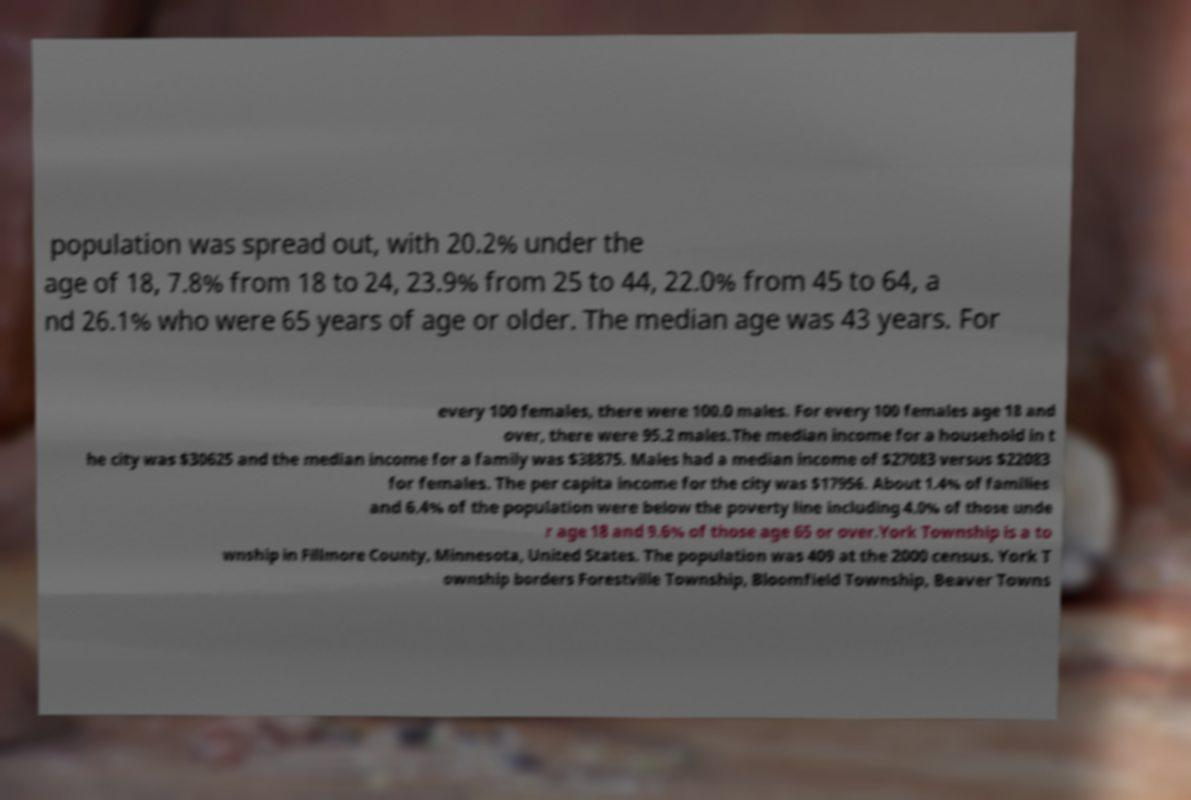What messages or text are displayed in this image? I need them in a readable, typed format. population was spread out, with 20.2% under the age of 18, 7.8% from 18 to 24, 23.9% from 25 to 44, 22.0% from 45 to 64, a nd 26.1% who were 65 years of age or older. The median age was 43 years. For every 100 females, there were 100.0 males. For every 100 females age 18 and over, there were 95.2 males.The median income for a household in t he city was $30625 and the median income for a family was $38875. Males had a median income of $27083 versus $22083 for females. The per capita income for the city was $17956. About 1.4% of families and 6.4% of the population were below the poverty line including 4.0% of those unde r age 18 and 9.6% of those age 65 or over.York Township is a to wnship in Fillmore County, Minnesota, United States. The population was 409 at the 2000 census. York T ownship borders Forestville Township, Bloomfield Township, Beaver Towns 